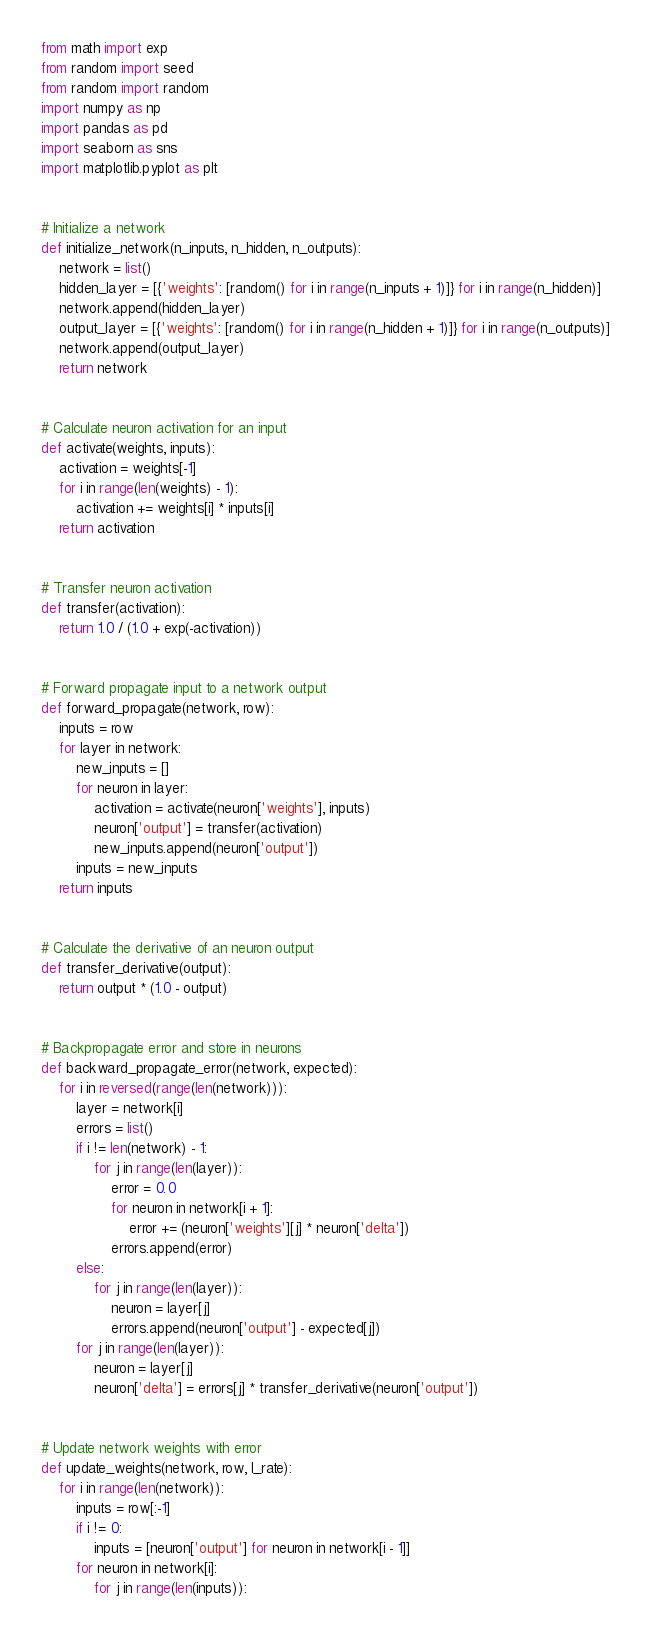Convert code to text. <code><loc_0><loc_0><loc_500><loc_500><_Python_>from math import exp
from random import seed
from random import random
import numpy as np
import pandas as pd
import seaborn as sns
import matplotlib.pyplot as plt


# Initialize a network
def initialize_network(n_inputs, n_hidden, n_outputs):
    network = list()
    hidden_layer = [{'weights': [random() for i in range(n_inputs + 1)]} for i in range(n_hidden)]
    network.append(hidden_layer)
    output_layer = [{'weights': [random() for i in range(n_hidden + 1)]} for i in range(n_outputs)]
    network.append(output_layer)
    return network


# Calculate neuron activation for an input
def activate(weights, inputs):
    activation = weights[-1]
    for i in range(len(weights) - 1):
        activation += weights[i] * inputs[i]
    return activation


# Transfer neuron activation
def transfer(activation):
    return 1.0 / (1.0 + exp(-activation))


# Forward propagate input to a network output
def forward_propagate(network, row):
    inputs = row
    for layer in network:
        new_inputs = []
        for neuron in layer:
            activation = activate(neuron['weights'], inputs)
            neuron['output'] = transfer(activation)
            new_inputs.append(neuron['output'])
        inputs = new_inputs
    return inputs


# Calculate the derivative of an neuron output
def transfer_derivative(output):
    return output * (1.0 - output)


# Backpropagate error and store in neurons
def backward_propagate_error(network, expected):
    for i in reversed(range(len(network))):
        layer = network[i]
        errors = list()
        if i != len(network) - 1:
            for j in range(len(layer)):
                error = 0.0
                for neuron in network[i + 1]:
                    error += (neuron['weights'][j] * neuron['delta'])
                errors.append(error)
        else:
            for j in range(len(layer)):
                neuron = layer[j]
                errors.append(neuron['output'] - expected[j])
        for j in range(len(layer)):
            neuron = layer[j]
            neuron['delta'] = errors[j] * transfer_derivative(neuron['output'])


# Update network weights with error
def update_weights(network, row, l_rate):
    for i in range(len(network)):
        inputs = row[:-1]
        if i != 0:
            inputs = [neuron['output'] for neuron in network[i - 1]]
        for neuron in network[i]:
            for j in range(len(inputs)):</code> 